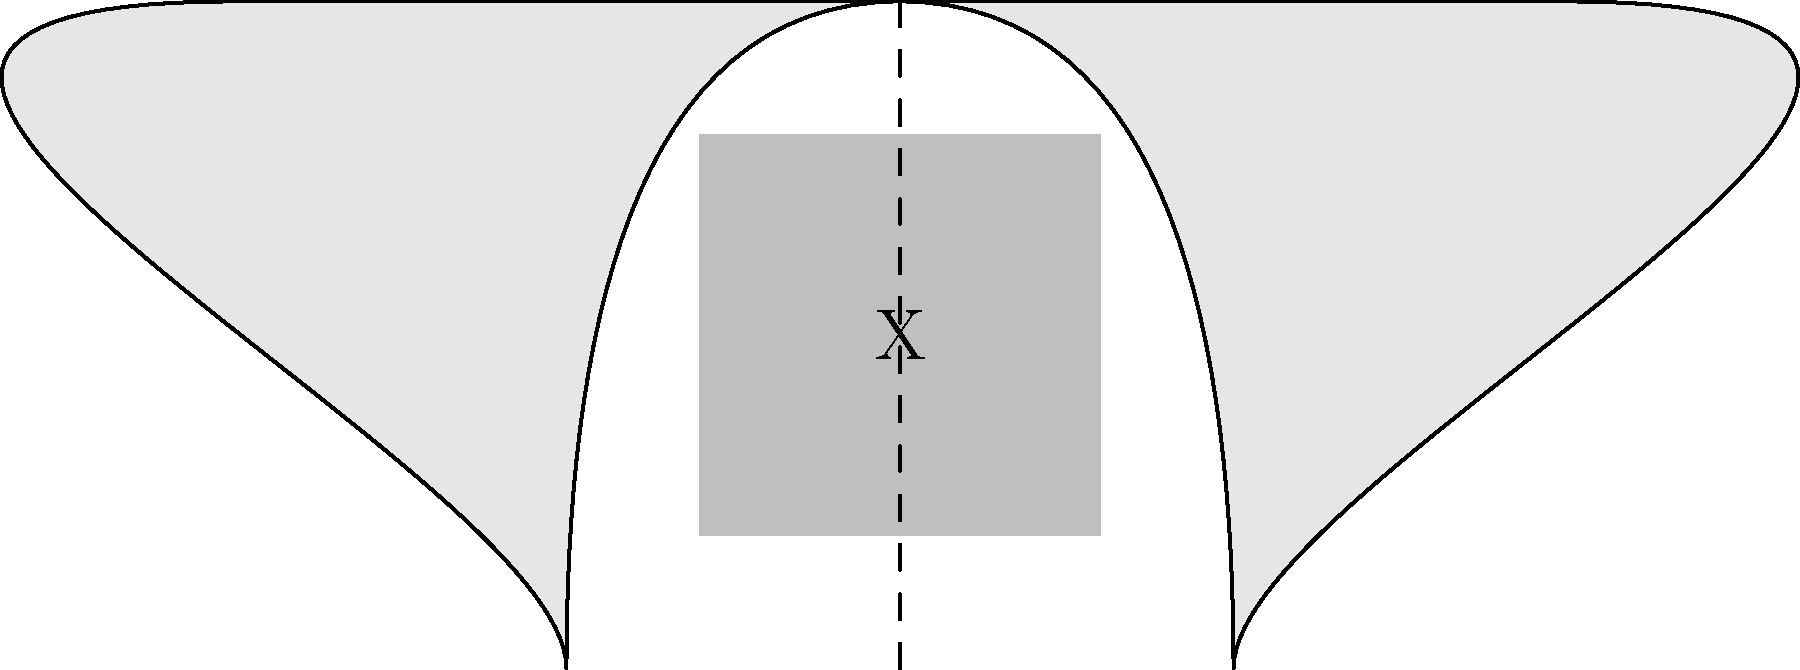In the chest X-ray image above, what does the area marked "X" likely represent, and what common respiratory condition might it indicate? To interpret this chest X-ray image and identify the likely condition, let's follow these steps:

1. Observe the overall structure:
   - The image shows a simplified representation of two lungs.
   - There's a vertical dashed line representing the midline or spine.

2. Examine the area marked "X":
   - It appears as a gray, opaque area in the right lung field.
   - The opacity is not uniform across the entire lung.

3. Consider the characteristics of the opacity:
   - It's localized to one area rather than diffuse throughout the lung.
   - The edges are somewhat ill-defined, not sharp or clearly demarcated.

4. Relate these findings to common respiratory conditions:
   - Localized opacity in one lung field often indicates consolidation.
   - Consolidation occurs when air in the alveoli is replaced by fluid, pus, blood, or cells.

5. Identify the most likely condition:
   - Given the localized consolidation, the most common cause in clinical practice is pneumonia.
   - Pneumonia is an infection that inflames the air sacs in one or both lungs, which may fill with fluid.

6. Consider the nursing implications:
   - As a nurse, recognizing this pattern is crucial for early identification of potential pneumonia cases.
   - This finding would prompt further clinical correlation, such as assessing for fever, cough, and shortness of breath.
Answer: Pneumonia 